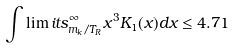Convert formula to latex. <formula><loc_0><loc_0><loc_500><loc_500>\int \lim i t s _ { m _ { k } / T _ { R } } ^ { \infty } x ^ { 3 } K _ { 1 } ( x ) d x \leq 4 . 7 1</formula> 